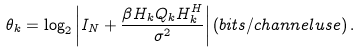Convert formula to latex. <formula><loc_0><loc_0><loc_500><loc_500>\theta _ { k } = \log _ { 2 } \left | I _ { N } + \frac { \beta H _ { k } Q _ { k } H _ { k } ^ { H } } { \sigma ^ { 2 } } \right | \left ( b i t s / c h a n n e l u s e \right ) .</formula> 